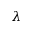<formula> <loc_0><loc_0><loc_500><loc_500>\lambda</formula> 